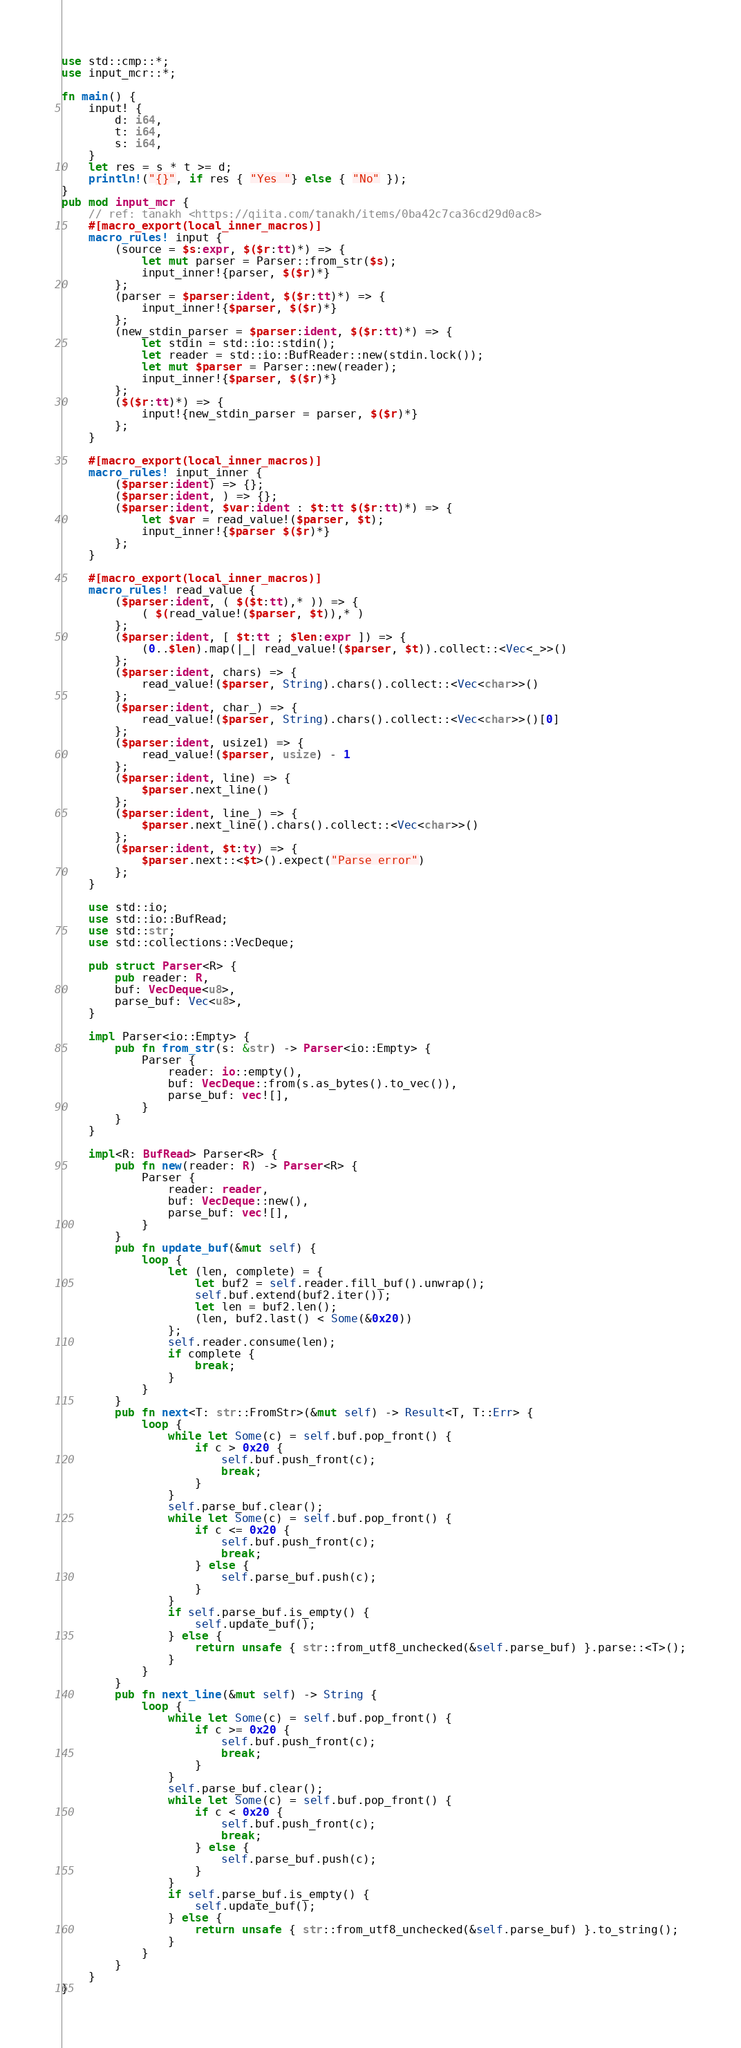Convert code to text. <code><loc_0><loc_0><loc_500><loc_500><_Rust_>use std::cmp::*;
use input_mcr::*;

fn main() {
    input! {
        d: i64,
        t: i64,
        s: i64,
    }
    let res = s * t >= d;
    println!("{}", if res { "Yes "} else { "No" });
}
pub mod input_mcr {
    // ref: tanakh <https://qiita.com/tanakh/items/0ba42c7ca36cd29d0ac8>
    #[macro_export(local_inner_macros)]
    macro_rules! input {
        (source = $s:expr, $($r:tt)*) => {
            let mut parser = Parser::from_str($s);
            input_inner!{parser, $($r)*}
        };
        (parser = $parser:ident, $($r:tt)*) => {
            input_inner!{$parser, $($r)*}
        };
        (new_stdin_parser = $parser:ident, $($r:tt)*) => {
            let stdin = std::io::stdin();
            let reader = std::io::BufReader::new(stdin.lock());
            let mut $parser = Parser::new(reader);
            input_inner!{$parser, $($r)*}
        };
        ($($r:tt)*) => {
            input!{new_stdin_parser = parser, $($r)*}
        };
    }
    
    #[macro_export(local_inner_macros)]
    macro_rules! input_inner {
        ($parser:ident) => {};
        ($parser:ident, ) => {};
        ($parser:ident, $var:ident : $t:tt $($r:tt)*) => {
            let $var = read_value!($parser, $t);
            input_inner!{$parser $($r)*}
        };
    }
    
    #[macro_export(local_inner_macros)]
    macro_rules! read_value {
        ($parser:ident, ( $($t:tt),* )) => {
            ( $(read_value!($parser, $t)),* )
        };
        ($parser:ident, [ $t:tt ; $len:expr ]) => {
            (0..$len).map(|_| read_value!($parser, $t)).collect::<Vec<_>>()
        };
        ($parser:ident, chars) => {
            read_value!($parser, String).chars().collect::<Vec<char>>()
        };
        ($parser:ident, char_) => {
            read_value!($parser, String).chars().collect::<Vec<char>>()[0]
        };
        ($parser:ident, usize1) => {
            read_value!($parser, usize) - 1
        };
        ($parser:ident, line) => {
            $parser.next_line()
        };
        ($parser:ident, line_) => {
            $parser.next_line().chars().collect::<Vec<char>>()
        };
        ($parser:ident, $t:ty) => {
            $parser.next::<$t>().expect("Parse error")
        };
    }
    
    use std::io;
    use std::io::BufRead;
    use std::str;
    use std::collections::VecDeque;
    
    pub struct Parser<R> {
        pub reader: R,
        buf: VecDeque<u8>,
        parse_buf: Vec<u8>,
    }
    
    impl Parser<io::Empty> {
        pub fn from_str(s: &str) -> Parser<io::Empty> {
            Parser {
                reader: io::empty(),
                buf: VecDeque::from(s.as_bytes().to_vec()),
                parse_buf: vec![],
            }
        }
    }
    
    impl<R: BufRead> Parser<R> {
        pub fn new(reader: R) -> Parser<R> {
            Parser {
                reader: reader,
                buf: VecDeque::new(),
                parse_buf: vec![],
            }
        }
        pub fn update_buf(&mut self) {
            loop {
                let (len, complete) = {
                    let buf2 = self.reader.fill_buf().unwrap();
                    self.buf.extend(buf2.iter());
                    let len = buf2.len();
                    (len, buf2.last() < Some(&0x20))
                };
                self.reader.consume(len);
                if complete {
                    break;
                }
            }
        }
        pub fn next<T: str::FromStr>(&mut self) -> Result<T, T::Err> {
            loop {
                while let Some(c) = self.buf.pop_front() {
                    if c > 0x20 {
                        self.buf.push_front(c);
                        break;
                    }
                }
                self.parse_buf.clear();
                while let Some(c) = self.buf.pop_front() {
                    if c <= 0x20 {
                        self.buf.push_front(c);
                        break;
                    } else {
                        self.parse_buf.push(c);
                    }
                }
                if self.parse_buf.is_empty() {
                    self.update_buf();
                } else {
                    return unsafe { str::from_utf8_unchecked(&self.parse_buf) }.parse::<T>();
                }
            }
        }
        pub fn next_line(&mut self) -> String {
            loop {
                while let Some(c) = self.buf.pop_front() {
                    if c >= 0x20 {
                        self.buf.push_front(c);
                        break;
                    }
                }
                self.parse_buf.clear();
                while let Some(c) = self.buf.pop_front() {
                    if c < 0x20 {
                        self.buf.push_front(c);
                        break;
                    } else {
                        self.parse_buf.push(c);
                    }
                }
                if self.parse_buf.is_empty() {
                    self.update_buf();
                } else {
                    return unsafe { str::from_utf8_unchecked(&self.parse_buf) }.to_string();
                }
            }
        }
    }
}

</code> 